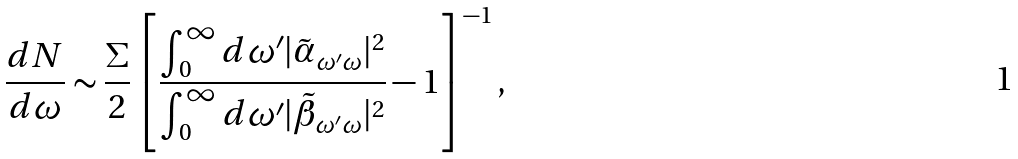Convert formula to latex. <formula><loc_0><loc_0><loc_500><loc_500>\frac { d N } { d \omega } \sim \frac { \Sigma } { 2 } \left [ \frac { \int _ { 0 } ^ { \infty } d \omega ^ { \prime } | \tilde { \alpha } _ { \omega ^ { \prime } \omega } | ^ { 2 } } { \int _ { 0 } ^ { \infty } d \omega ^ { \prime } | \tilde { \beta } _ { \omega ^ { \prime } \omega } | ^ { 2 } } - 1 \right ] ^ { - 1 } ,</formula> 